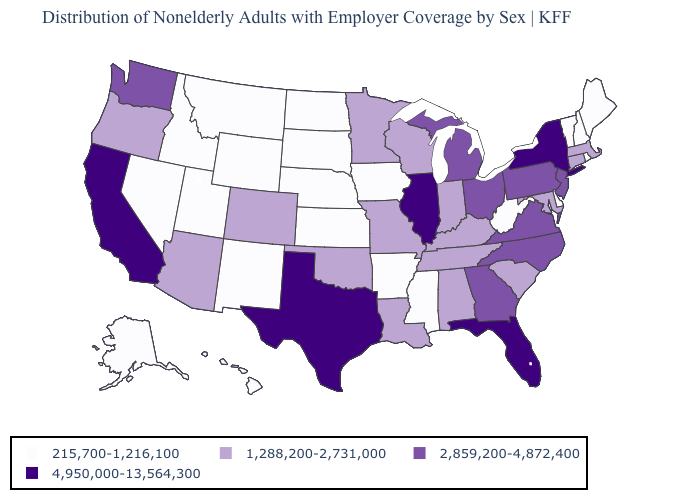What is the value of Georgia?
Answer briefly. 2,859,200-4,872,400. How many symbols are there in the legend?
Write a very short answer. 4. Name the states that have a value in the range 215,700-1,216,100?
Be succinct. Alaska, Arkansas, Delaware, Hawaii, Idaho, Iowa, Kansas, Maine, Mississippi, Montana, Nebraska, Nevada, New Hampshire, New Mexico, North Dakota, Rhode Island, South Dakota, Utah, Vermont, West Virginia, Wyoming. What is the value of Kansas?
Short answer required. 215,700-1,216,100. Does the first symbol in the legend represent the smallest category?
Quick response, please. Yes. What is the value of Maine?
Short answer required. 215,700-1,216,100. What is the value of New York?
Concise answer only. 4,950,000-13,564,300. Does Mississippi have the lowest value in the USA?
Concise answer only. Yes. What is the lowest value in states that border Colorado?
Keep it brief. 215,700-1,216,100. What is the value of Massachusetts?
Quick response, please. 1,288,200-2,731,000. Among the states that border New Hampshire , which have the highest value?
Give a very brief answer. Massachusetts. Does Idaho have the lowest value in the USA?
Be succinct. Yes. What is the value of Nevada?
Quick response, please. 215,700-1,216,100. What is the value of Georgia?
Concise answer only. 2,859,200-4,872,400. Name the states that have a value in the range 2,859,200-4,872,400?
Write a very short answer. Georgia, Michigan, New Jersey, North Carolina, Ohio, Pennsylvania, Virginia, Washington. 